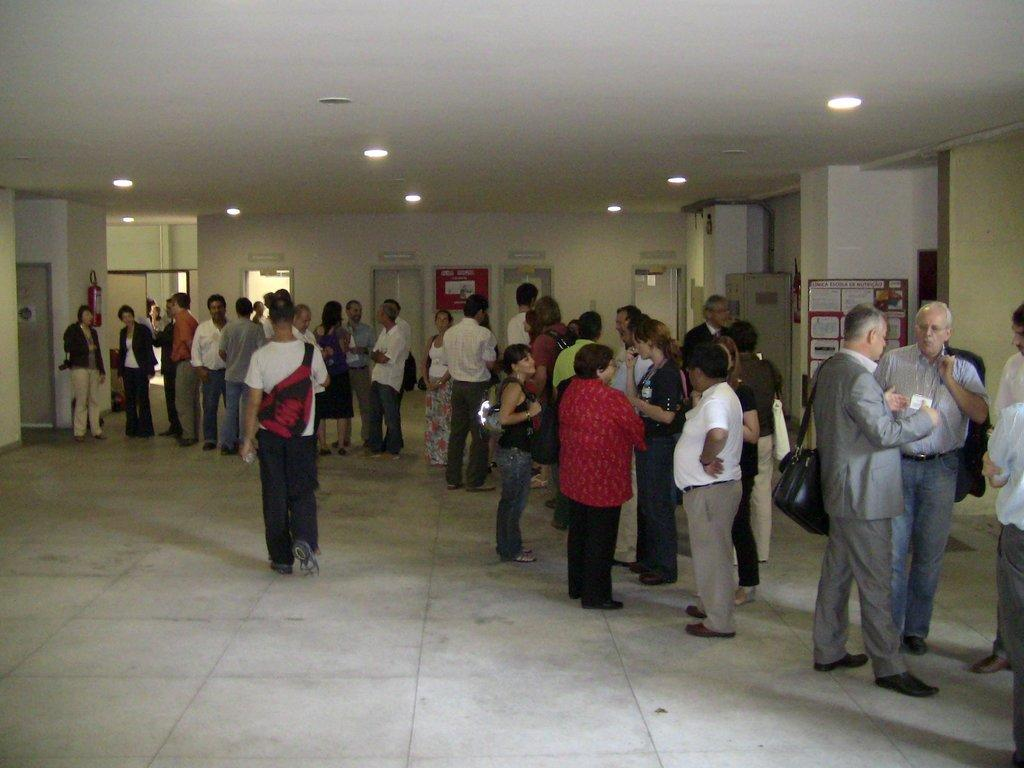What type of space is depicted in the image? The image is of a room. What type of lighting is present in the room? There are ceiling lights in the room. Are there any people present in the room? Yes, there are people in the room. How many doors are in the room? There are doors in the room. What surrounds the room? There are walls in the room. What safety device is present in the room? There is a fire extinguisher in the room. What type of objects can be seen on the walls? There are boards in the room. Can you describe any other objects in the room that are not specifically mentioned? There are "things" in the room, which could refer to various objects not specifically mentioned. What type of hat is the needle wearing in the image? There is no hat or needle present in the image. What act are the people in the room performing? The image does not depict any specific act or performance; it simply shows a room with people in it. 